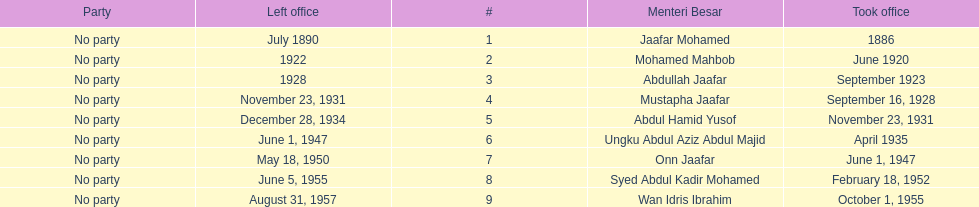Who spend the most amount of time in office? Ungku Abdul Aziz Abdul Majid. 